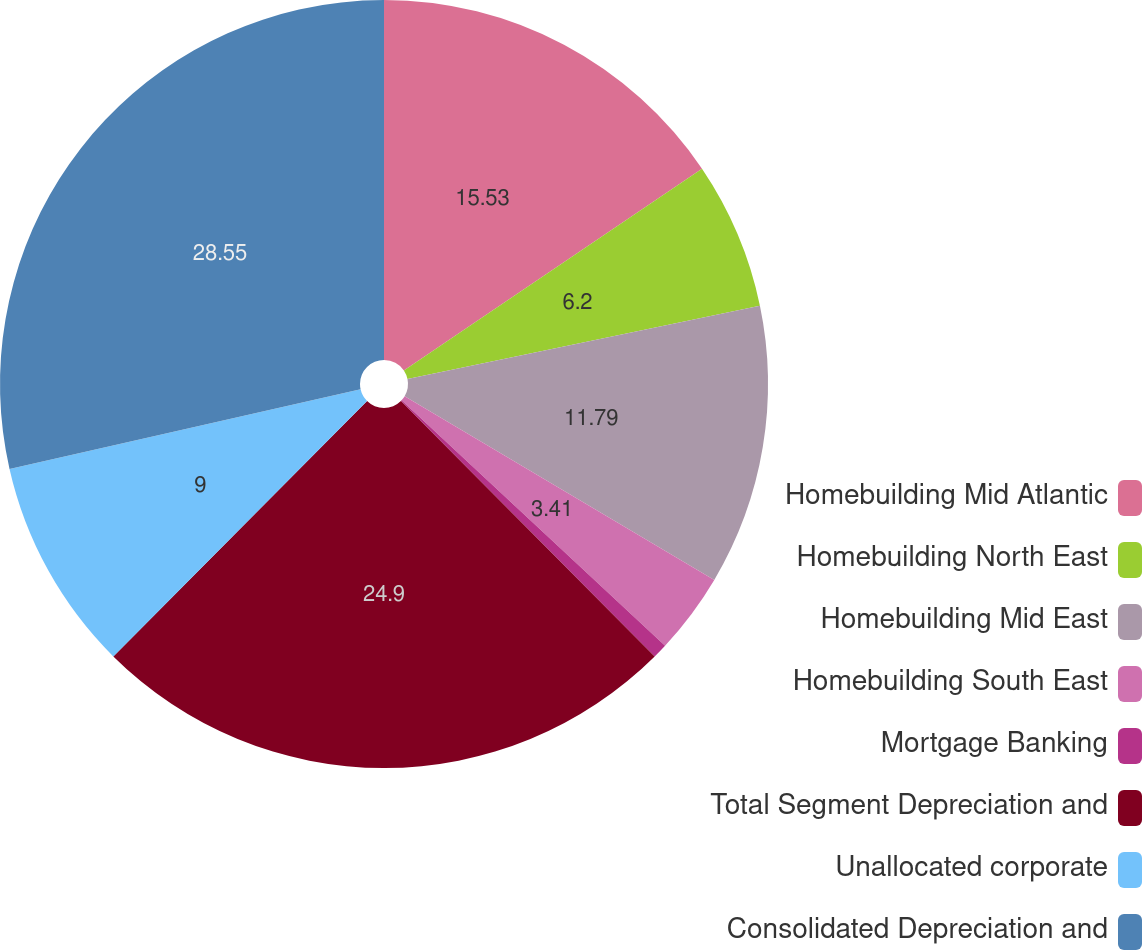Convert chart. <chart><loc_0><loc_0><loc_500><loc_500><pie_chart><fcel>Homebuilding Mid Atlantic<fcel>Homebuilding North East<fcel>Homebuilding Mid East<fcel>Homebuilding South East<fcel>Mortgage Banking<fcel>Total Segment Depreciation and<fcel>Unallocated corporate<fcel>Consolidated Depreciation and<nl><fcel>15.53%<fcel>6.2%<fcel>11.79%<fcel>3.41%<fcel>0.62%<fcel>24.9%<fcel>9.0%<fcel>28.55%<nl></chart> 